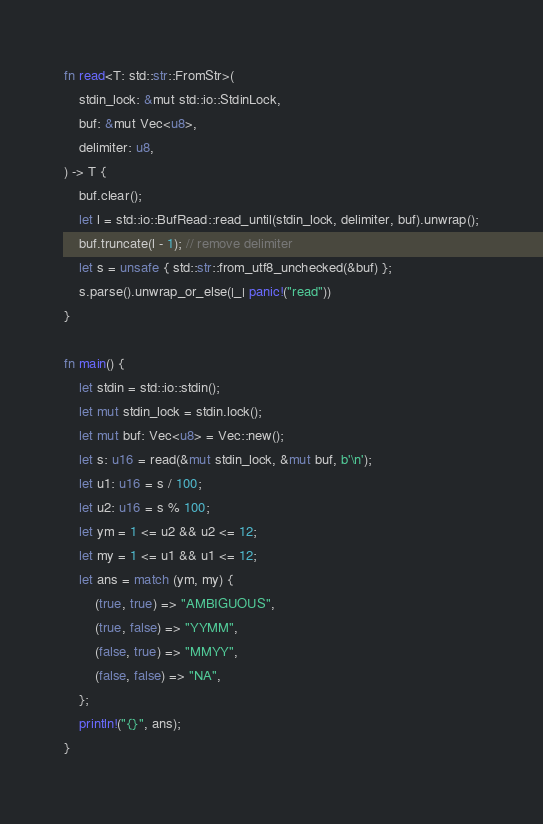<code> <loc_0><loc_0><loc_500><loc_500><_Rust_>fn read<T: std::str::FromStr>(
    stdin_lock: &mut std::io::StdinLock,
    buf: &mut Vec<u8>,
    delimiter: u8,
) -> T {
    buf.clear();
    let l = std::io::BufRead::read_until(stdin_lock, delimiter, buf).unwrap();
    buf.truncate(l - 1); // remove delimiter
    let s = unsafe { std::str::from_utf8_unchecked(&buf) };
    s.parse().unwrap_or_else(|_| panic!("read"))
}

fn main() {
    let stdin = std::io::stdin();
    let mut stdin_lock = stdin.lock();
    let mut buf: Vec<u8> = Vec::new();
    let s: u16 = read(&mut stdin_lock, &mut buf, b'\n');
    let u1: u16 = s / 100;
    let u2: u16 = s % 100;
    let ym = 1 <= u2 && u2 <= 12;
    let my = 1 <= u1 && u1 <= 12;
    let ans = match (ym, my) {
        (true, true) => "AMBIGUOUS",
        (true, false) => "YYMM",
        (false, true) => "MMYY",
        (false, false) => "NA",
    };
    println!("{}", ans);
}
</code> 